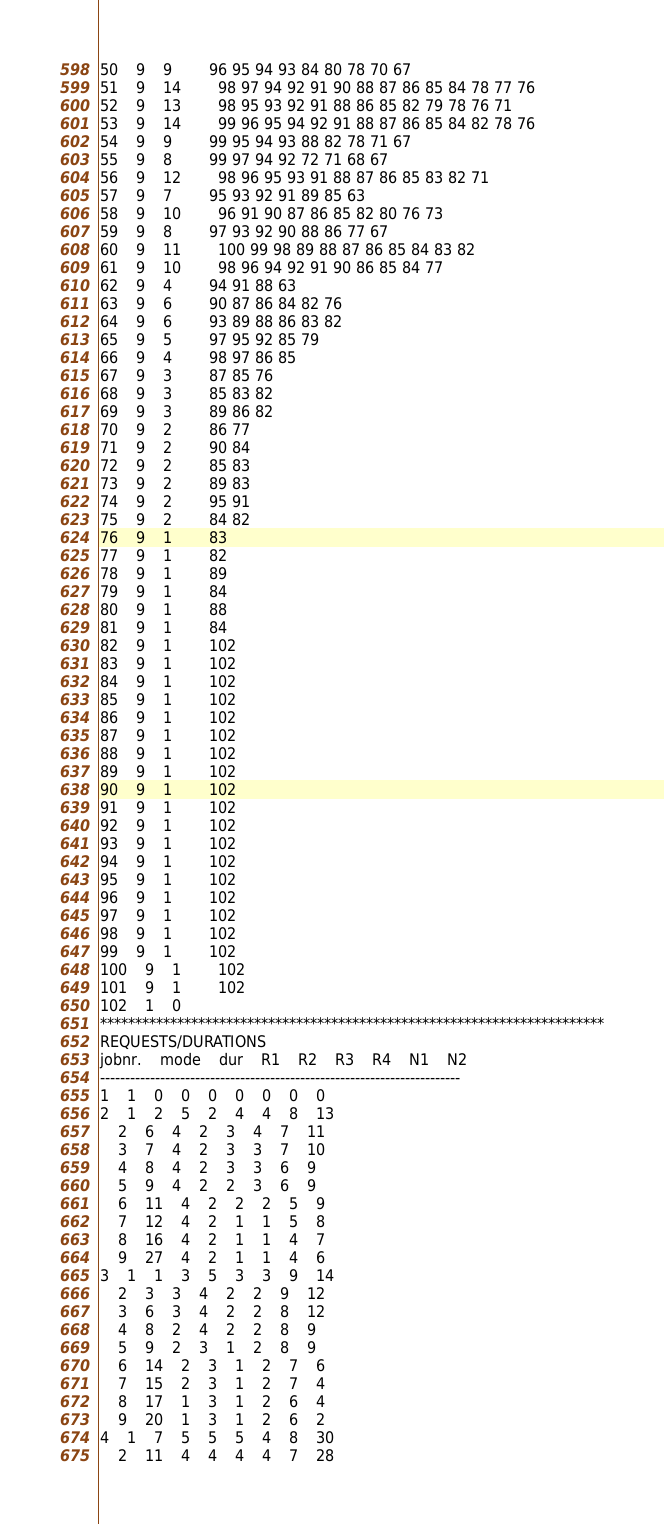<code> <loc_0><loc_0><loc_500><loc_500><_ObjectiveC_>50	9	9		96 95 94 93 84 80 78 70 67 
51	9	14		98 97 94 92 91 90 88 87 86 85 84 78 77 76 
52	9	13		98 95 93 92 91 88 86 85 82 79 78 76 71 
53	9	14		99 96 95 94 92 91 88 87 86 85 84 82 78 76 
54	9	9		99 95 94 93 88 82 78 71 67 
55	9	8		99 97 94 92 72 71 68 67 
56	9	12		98 96 95 93 91 88 87 86 85 83 82 71 
57	9	7		95 93 92 91 89 85 63 
58	9	10		96 91 90 87 86 85 82 80 76 73 
59	9	8		97 93 92 90 88 86 77 67 
60	9	11		100 99 98 89 88 87 86 85 84 83 82 
61	9	10		98 96 94 92 91 90 86 85 84 77 
62	9	4		94 91 88 63 
63	9	6		90 87 86 84 82 76 
64	9	6		93 89 88 86 83 82 
65	9	5		97 95 92 85 79 
66	9	4		98 97 86 85 
67	9	3		87 85 76 
68	9	3		85 83 82 
69	9	3		89 86 82 
70	9	2		86 77 
71	9	2		90 84 
72	9	2		85 83 
73	9	2		89 83 
74	9	2		95 91 
75	9	2		84 82 
76	9	1		83 
77	9	1		82 
78	9	1		89 
79	9	1		84 
80	9	1		88 
81	9	1		84 
82	9	1		102 
83	9	1		102 
84	9	1		102 
85	9	1		102 
86	9	1		102 
87	9	1		102 
88	9	1		102 
89	9	1		102 
90	9	1		102 
91	9	1		102 
92	9	1		102 
93	9	1		102 
94	9	1		102 
95	9	1		102 
96	9	1		102 
97	9	1		102 
98	9	1		102 
99	9	1		102 
100	9	1		102 
101	9	1		102 
102	1	0		
************************************************************************
REQUESTS/DURATIONS
jobnr.	mode	dur	R1	R2	R3	R4	N1	N2	
------------------------------------------------------------------------
1	1	0	0	0	0	0	0	0	
2	1	2	5	2	4	4	8	13	
	2	6	4	2	3	4	7	11	
	3	7	4	2	3	3	7	10	
	4	8	4	2	3	3	6	9	
	5	9	4	2	2	3	6	9	
	6	11	4	2	2	2	5	9	
	7	12	4	2	1	1	5	8	
	8	16	4	2	1	1	4	7	
	9	27	4	2	1	1	4	6	
3	1	1	3	5	3	3	9	14	
	2	3	3	4	2	2	9	12	
	3	6	3	4	2	2	8	12	
	4	8	2	4	2	2	8	9	
	5	9	2	3	1	2	8	9	
	6	14	2	3	1	2	7	6	
	7	15	2	3	1	2	7	4	
	8	17	1	3	1	2	6	4	
	9	20	1	3	1	2	6	2	
4	1	7	5	5	5	4	8	30	
	2	11	4	4	4	4	7	28	</code> 